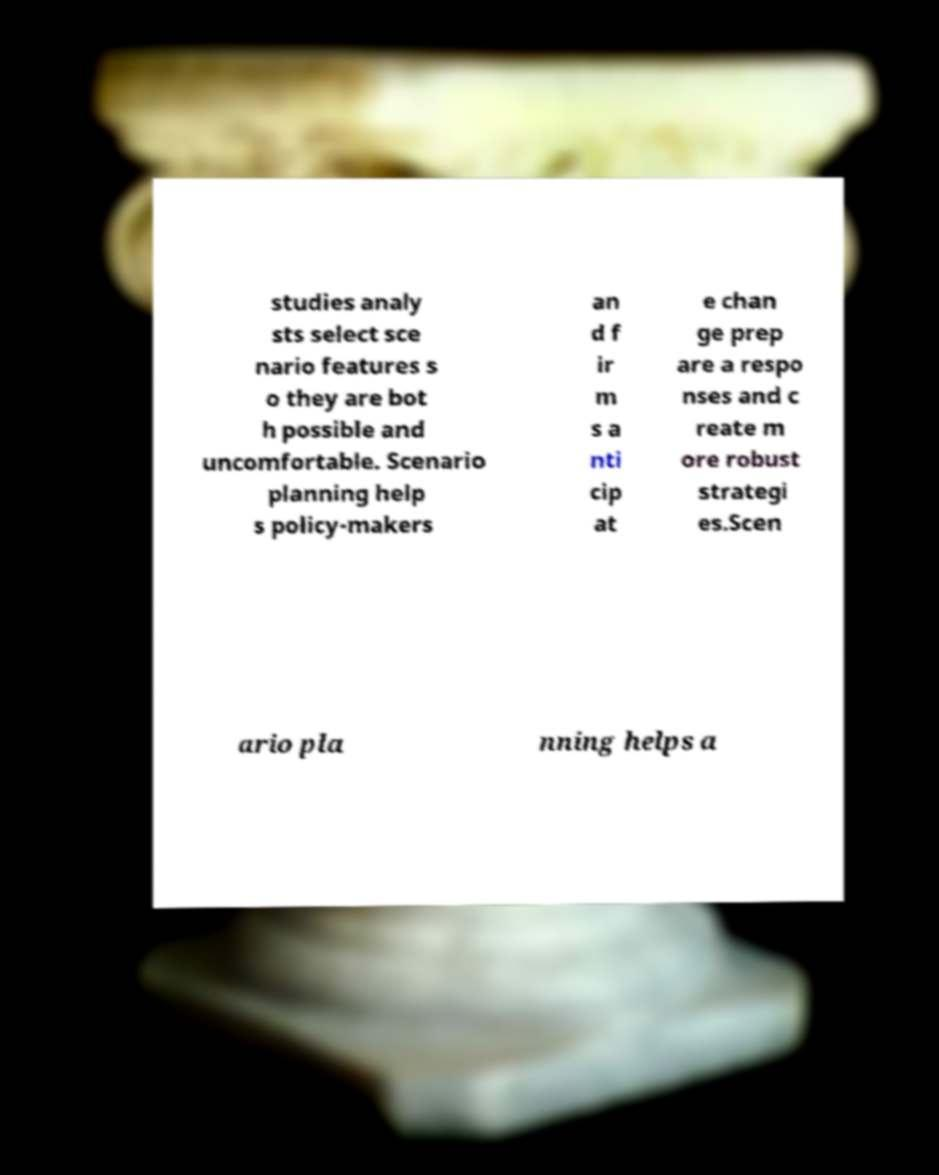Please identify and transcribe the text found in this image. studies analy sts select sce nario features s o they are bot h possible and uncomfortable. Scenario planning help s policy-makers an d f ir m s a nti cip at e chan ge prep are a respo nses and c reate m ore robust strategi es.Scen ario pla nning helps a 